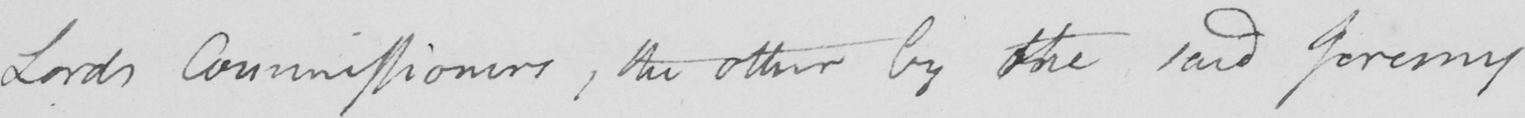What text is written in this handwritten line? Lords Commissioners , the other by the said Jeremy 